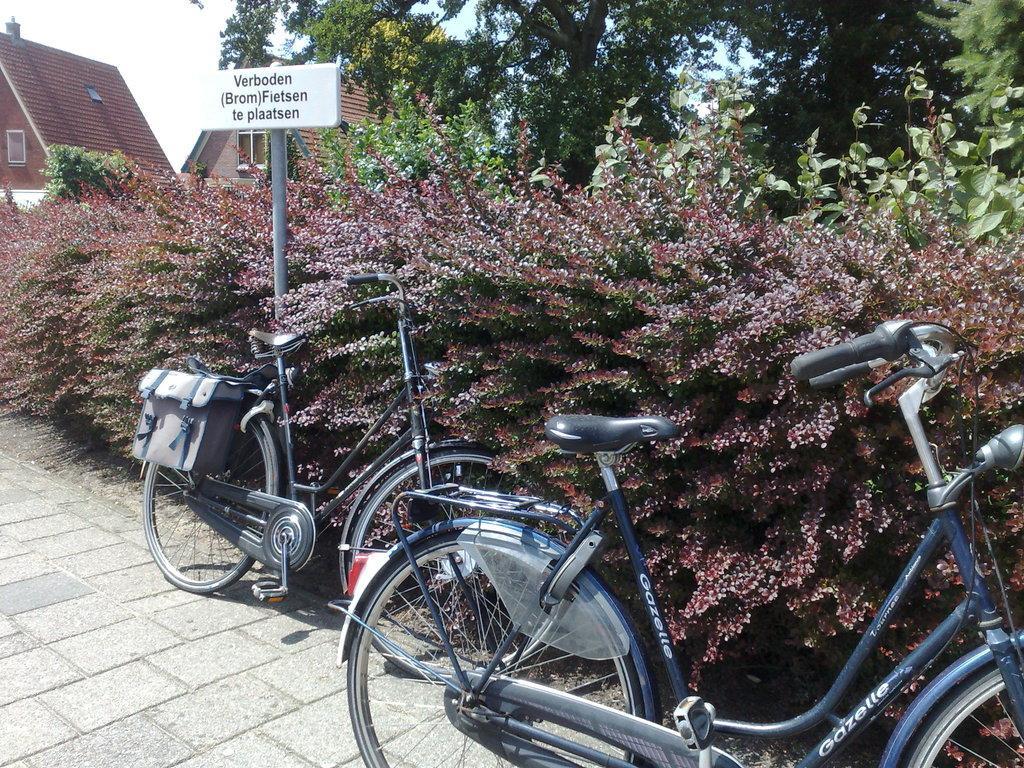How would you summarize this image in a sentence or two? In this picture we can see bicycles on the ground and in the background we can see a name board, trees, houses and the sky. 